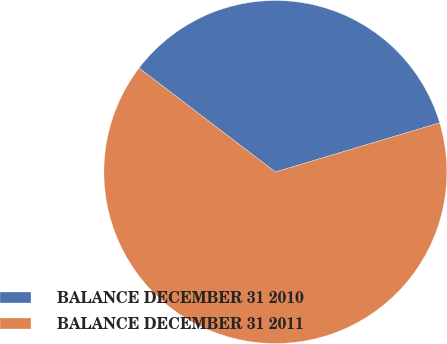<chart> <loc_0><loc_0><loc_500><loc_500><pie_chart><fcel>BALANCE DECEMBER 31 2010<fcel>BALANCE DECEMBER 31 2011<nl><fcel>35.0%<fcel>65.0%<nl></chart> 